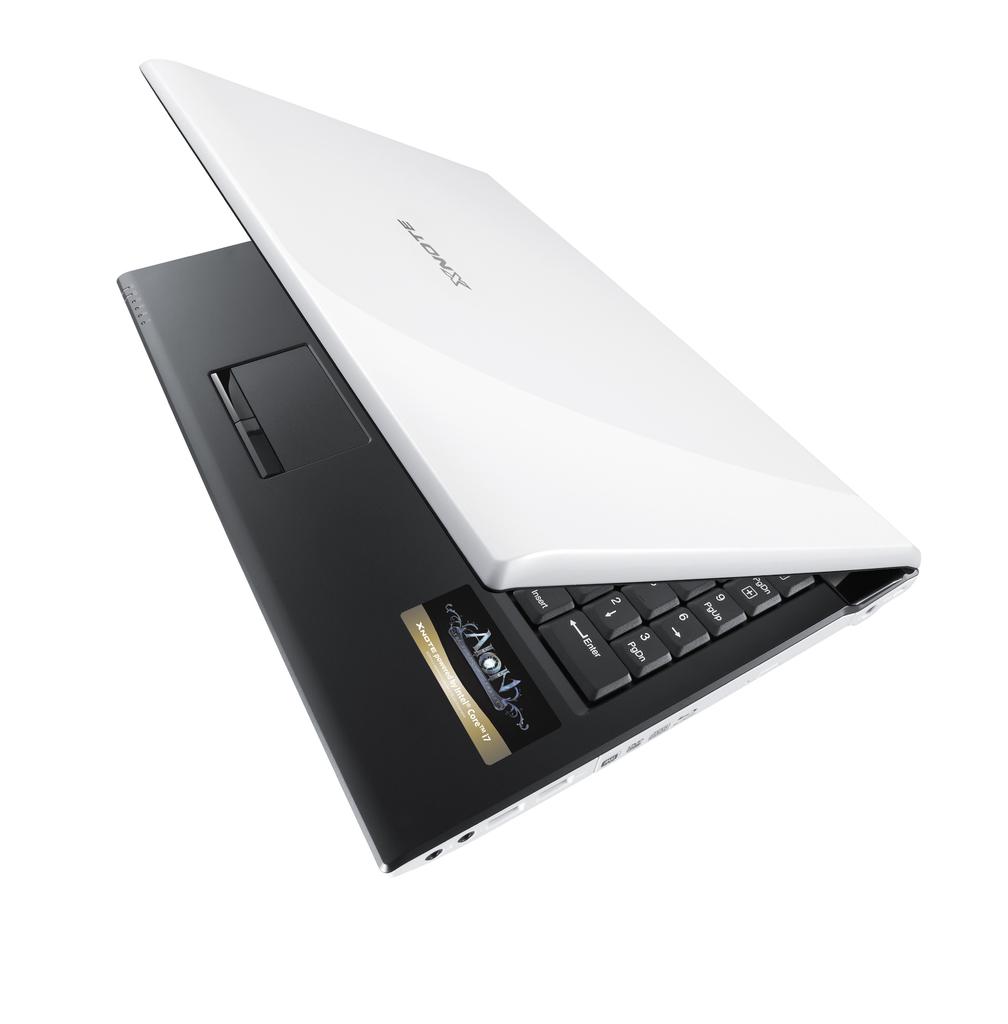What brand is on the sticker?
Offer a very short reply. Aion. What brand of laptop?
Your response must be concise. Xnote. 